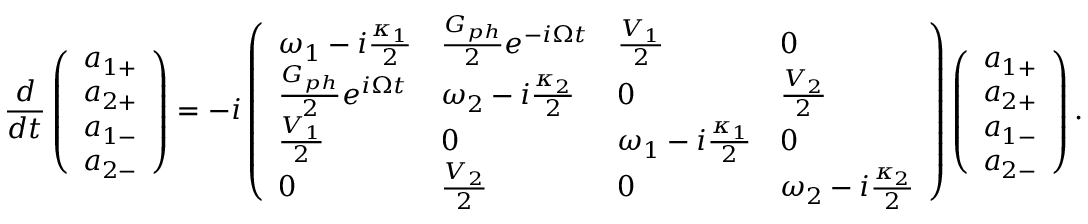Convert formula to latex. <formula><loc_0><loc_0><loc_500><loc_500>\frac { d } { d t } \left ( \begin{array} { l } { a _ { 1 + } } \\ { a _ { 2 + } } \\ { a _ { 1 - } } \\ { a _ { 2 - } } \end{array} \right ) = - i \left ( \begin{array} { l l l l } { \omega _ { 1 } - i \frac { \kappa _ { 1 } } { 2 } } & { \frac { G _ { p h } } { 2 } e ^ { - i \Omega t } } & { \frac { V _ { 1 } } { 2 } } & { 0 } \\ { \frac { G _ { p h } } { 2 } e ^ { i \Omega t } } & { \omega _ { 2 } - i \frac { \kappa _ { 2 } } { 2 } } & { 0 } & { \frac { V _ { 2 } } { 2 } } \\ { \frac { V _ { 1 } } { 2 } } & { 0 } & { \omega _ { 1 } - i \frac { \kappa _ { 1 } } { 2 } } & { 0 } \\ { 0 } & { \frac { V _ { 2 } } { 2 } } & { 0 } & { \omega _ { 2 } - i \frac { \kappa _ { 2 } } { 2 } } \end{array} \right ) \left ( \begin{array} { l } { a _ { 1 + } } \\ { a _ { 2 + } } \\ { a _ { 1 - } } \\ { a _ { 2 - } } \end{array} \right ) .</formula> 